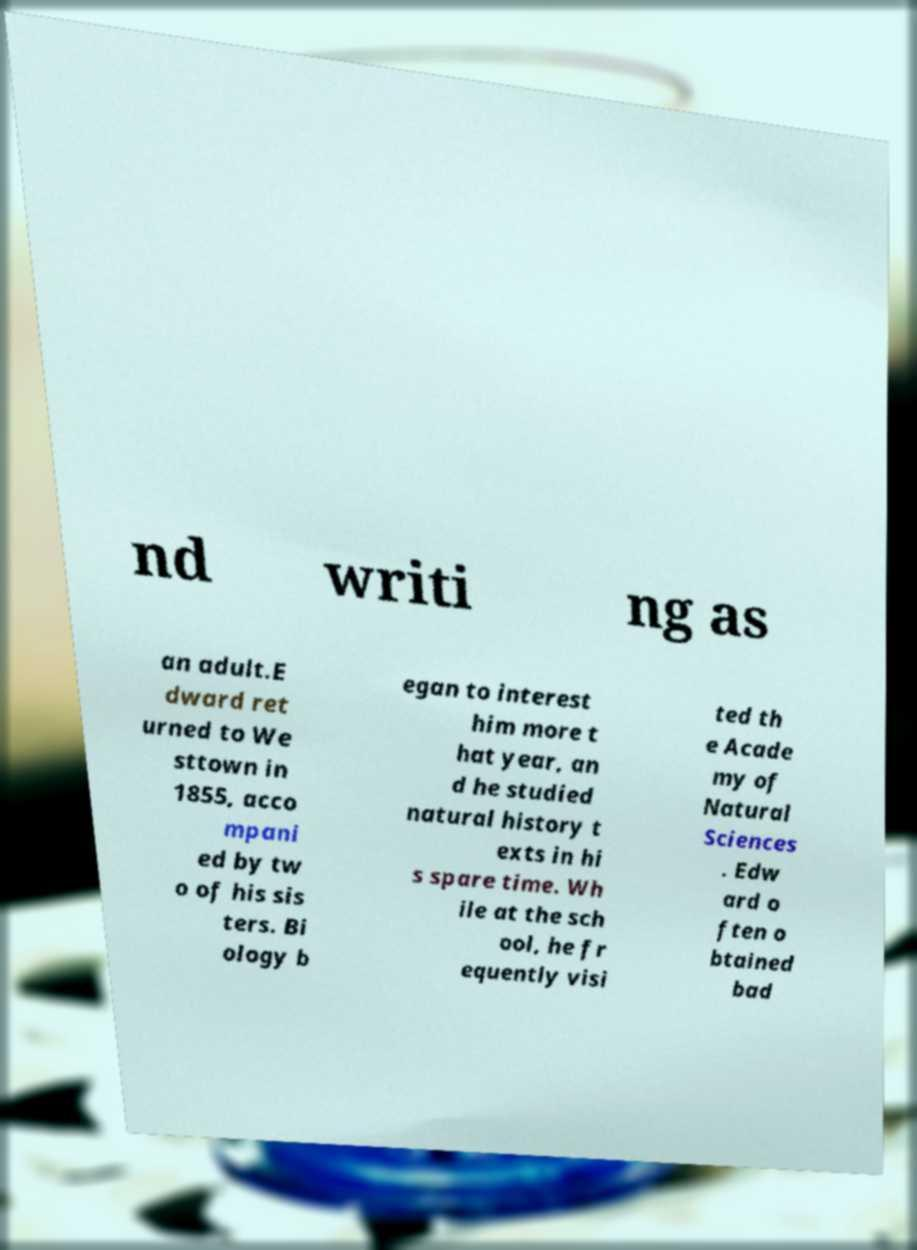There's text embedded in this image that I need extracted. Can you transcribe it verbatim? nd writi ng as an adult.E dward ret urned to We sttown in 1855, acco mpani ed by tw o of his sis ters. Bi ology b egan to interest him more t hat year, an d he studied natural history t exts in hi s spare time. Wh ile at the sch ool, he fr equently visi ted th e Acade my of Natural Sciences . Edw ard o ften o btained bad 